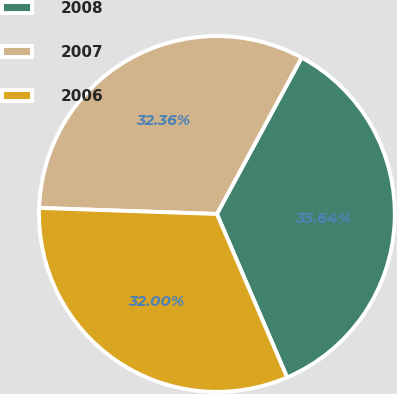<chart> <loc_0><loc_0><loc_500><loc_500><pie_chart><fcel>2008<fcel>2007<fcel>2006<nl><fcel>35.64%<fcel>32.36%<fcel>32.0%<nl></chart> 